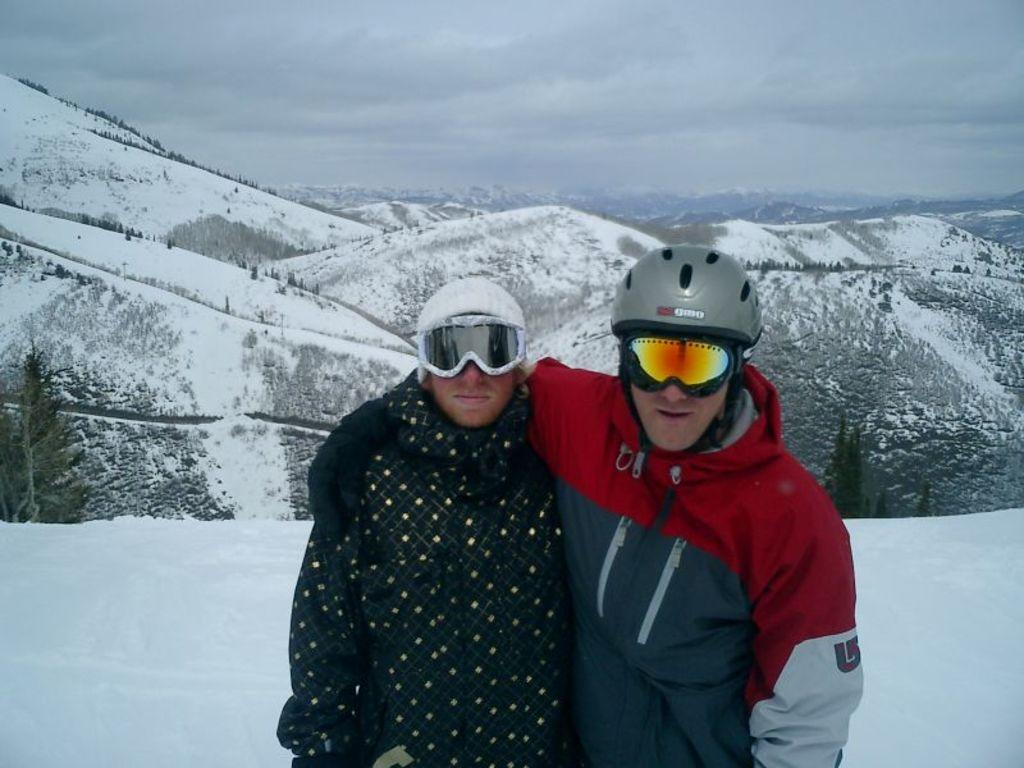How many people are in the image? There are two persons in the image. What is the surface they are standing on? The persons are standing on the snow. What type of clothing are the persons wearing on their upper bodies? The persons are wearing jackets. What type of protective gear are the persons wearing on their faces? The persons are wearing goggles. What type of protective gear are the persons wearing on their heads? The persons are wearing helmets. What can be seen in the background of the image? There are mountains and the sky visible in the background of the image. What type of trousers are the persons wearing in the image? The provided facts do not mention the type of trousers the persons are wearing. Are the persons in the image friends? The provided facts do not mention the relationship between the persons in the image. 